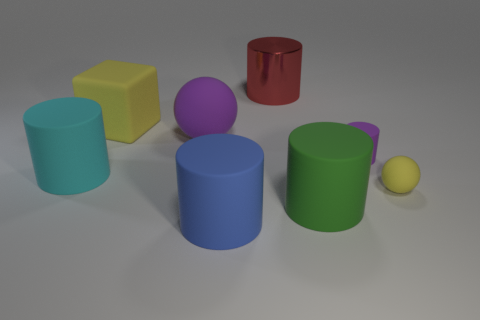Subtract all large green cylinders. How many cylinders are left? 4 Subtract all blue cylinders. How many cylinders are left? 4 Subtract all yellow cylinders. Subtract all red blocks. How many cylinders are left? 5 Add 1 purple rubber balls. How many objects exist? 9 Subtract all cubes. How many objects are left? 7 Subtract 1 yellow cubes. How many objects are left? 7 Subtract all cylinders. Subtract all big cyan shiny cylinders. How many objects are left? 3 Add 3 large cyan matte things. How many large cyan matte things are left? 4 Add 6 shiny spheres. How many shiny spheres exist? 6 